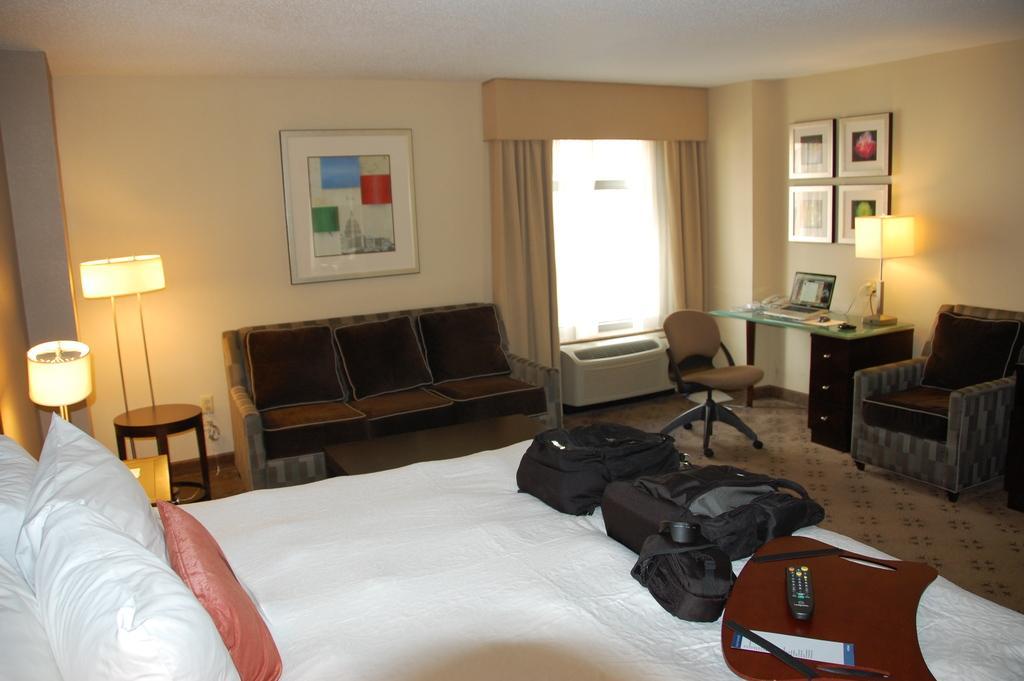Describe this image in one or two sentences. The picture is taken inside a room. There is bed with a white bed cover. There are pillows on the bed ,there are two backpacks,and a small bag,there is a board on it there is a remote. On the right hand there is a chair. Beside it there is a table on the table there is table lamp ,laptop. In front it there is a chair. On the wall there are pictures hanged. In the background there is window. there is curtains in the both side of the window. Beside the window there is a sofa. on the top of sofa there is picture hanged on the wall. Beside that there is table. on the table there is lamp. On the floor there is carpet. The wall is yellow in color. the roof is white in color. 